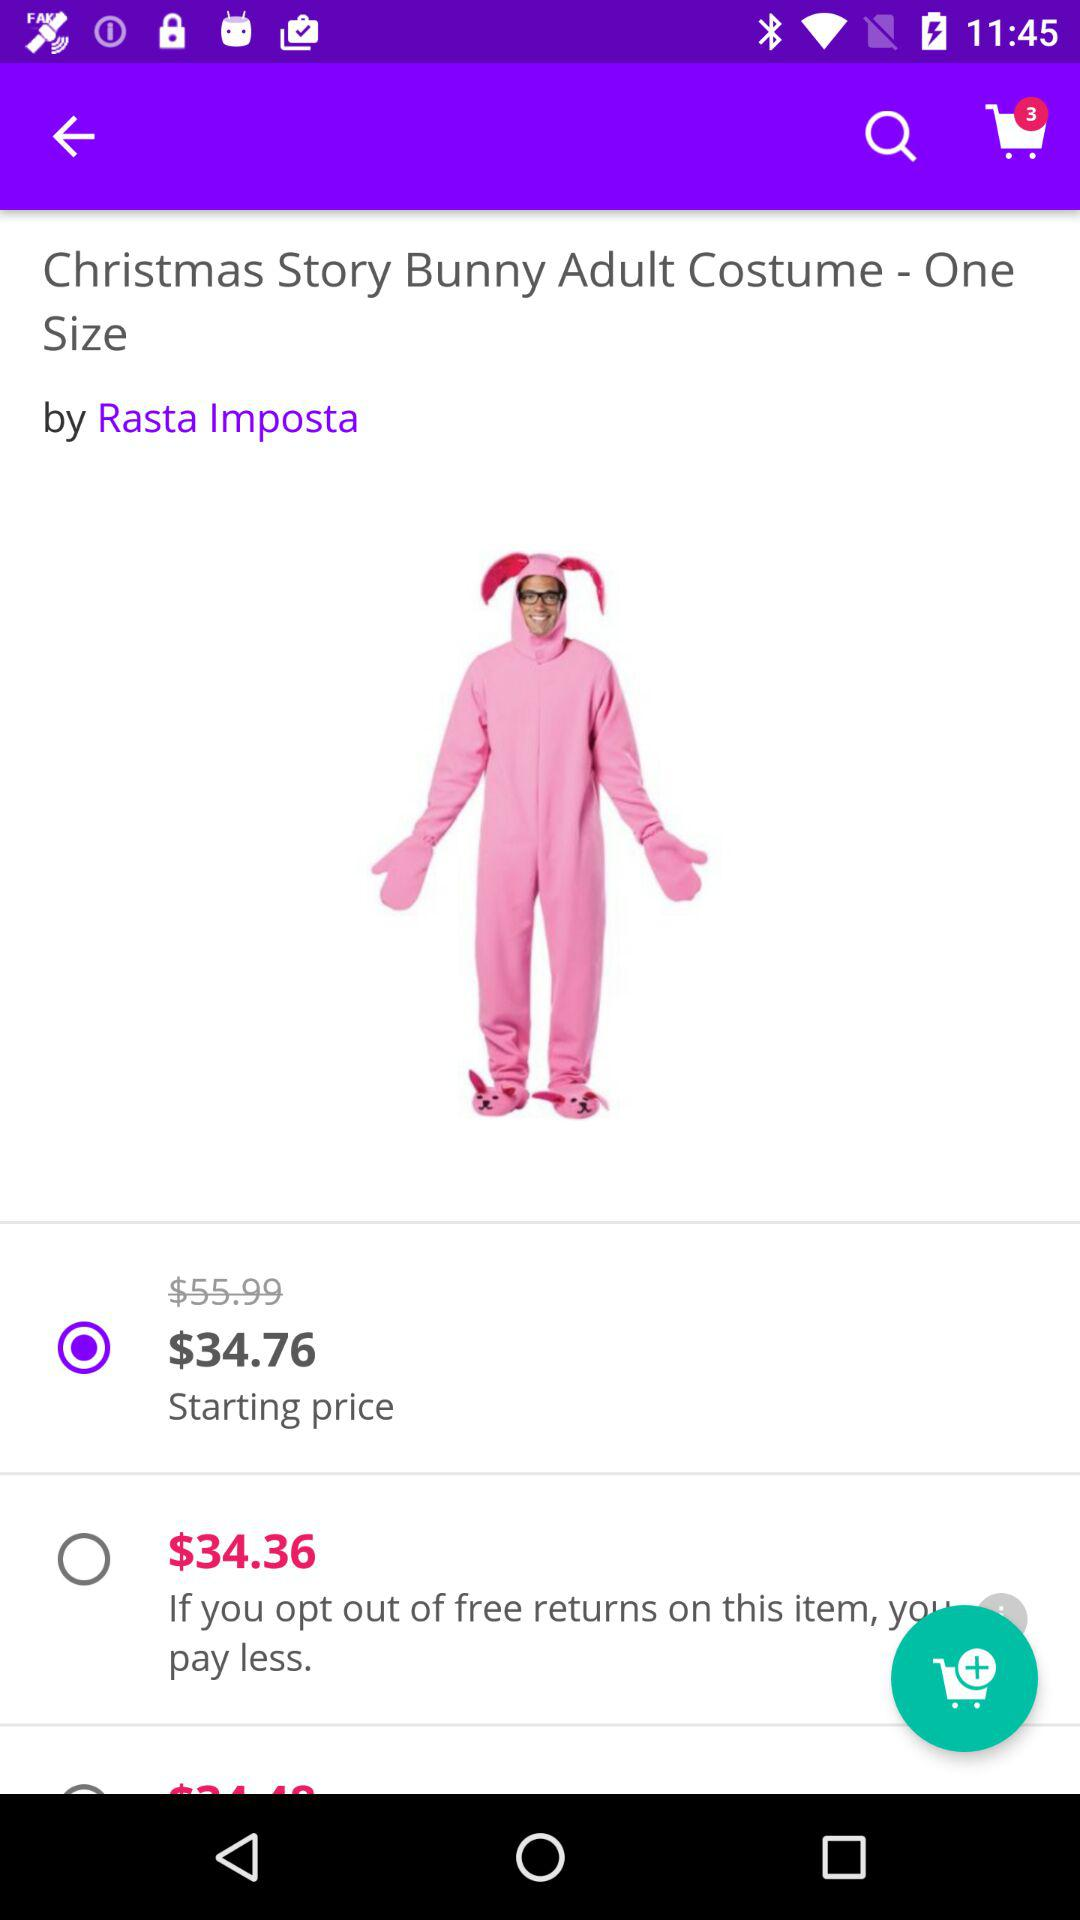When will $34.36 have to be paid? $34.36 will have to be paid if you opt out of free returns on the item. 